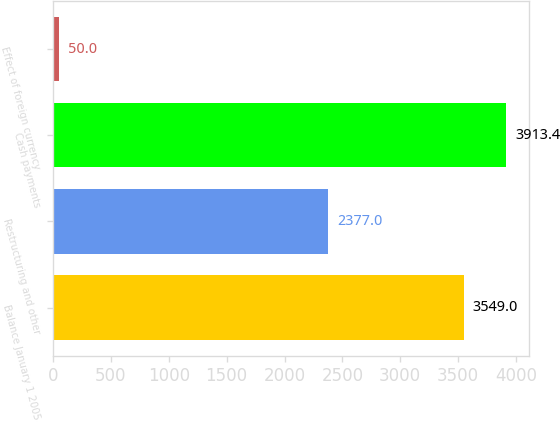Convert chart. <chart><loc_0><loc_0><loc_500><loc_500><bar_chart><fcel>Balance January 1 2005<fcel>Restructuring and other<fcel>Cash payments<fcel>Effect of foreign currency<nl><fcel>3549<fcel>2377<fcel>3913.4<fcel>50<nl></chart> 